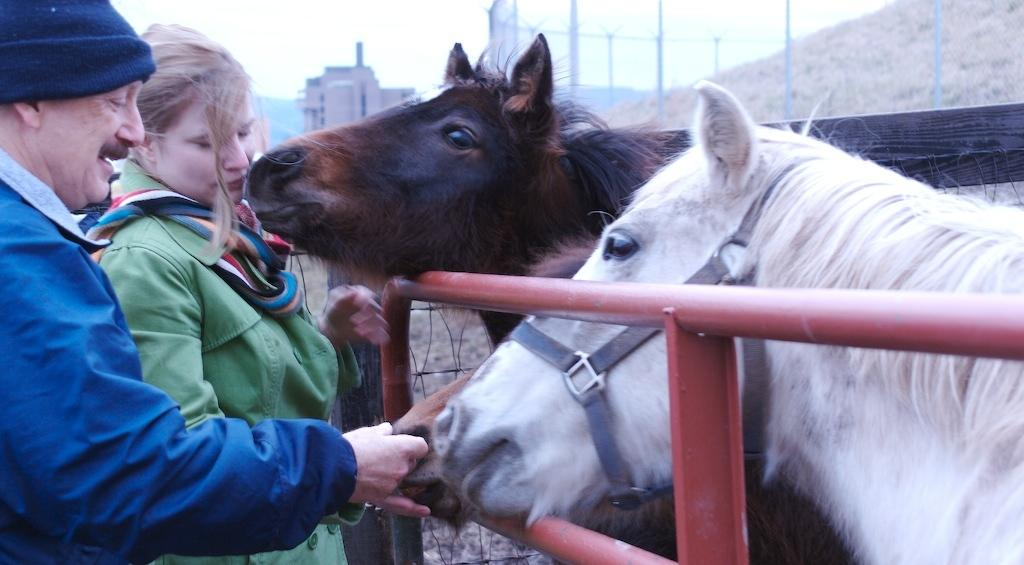What can be seen in the background of the image? There is a sky in the image. What type of structure is present in the image? There is a building in the image. What animals are visible in the image? There are horses in the image. Where are the people located in the image? There are two people on the left side of the image. What type of sheet is covering the horses in the image? There is no sheet covering the horses in the image; they are not covered at all. What type of meat is being served to the people on the left side of the image? There is no meat present in the image; the people are not eating or interacting with any food. 